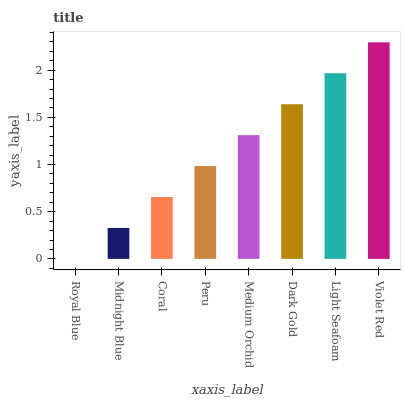Is Royal Blue the minimum?
Answer yes or no. Yes. Is Violet Red the maximum?
Answer yes or no. Yes. Is Midnight Blue the minimum?
Answer yes or no. No. Is Midnight Blue the maximum?
Answer yes or no. No. Is Midnight Blue greater than Royal Blue?
Answer yes or no. Yes. Is Royal Blue less than Midnight Blue?
Answer yes or no. Yes. Is Royal Blue greater than Midnight Blue?
Answer yes or no. No. Is Midnight Blue less than Royal Blue?
Answer yes or no. No. Is Medium Orchid the high median?
Answer yes or no. Yes. Is Peru the low median?
Answer yes or no. Yes. Is Violet Red the high median?
Answer yes or no. No. Is Dark Gold the low median?
Answer yes or no. No. 